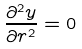Convert formula to latex. <formula><loc_0><loc_0><loc_500><loc_500>\frac { \partial ^ { 2 } y } { \partial r ^ { 2 } } = 0</formula> 